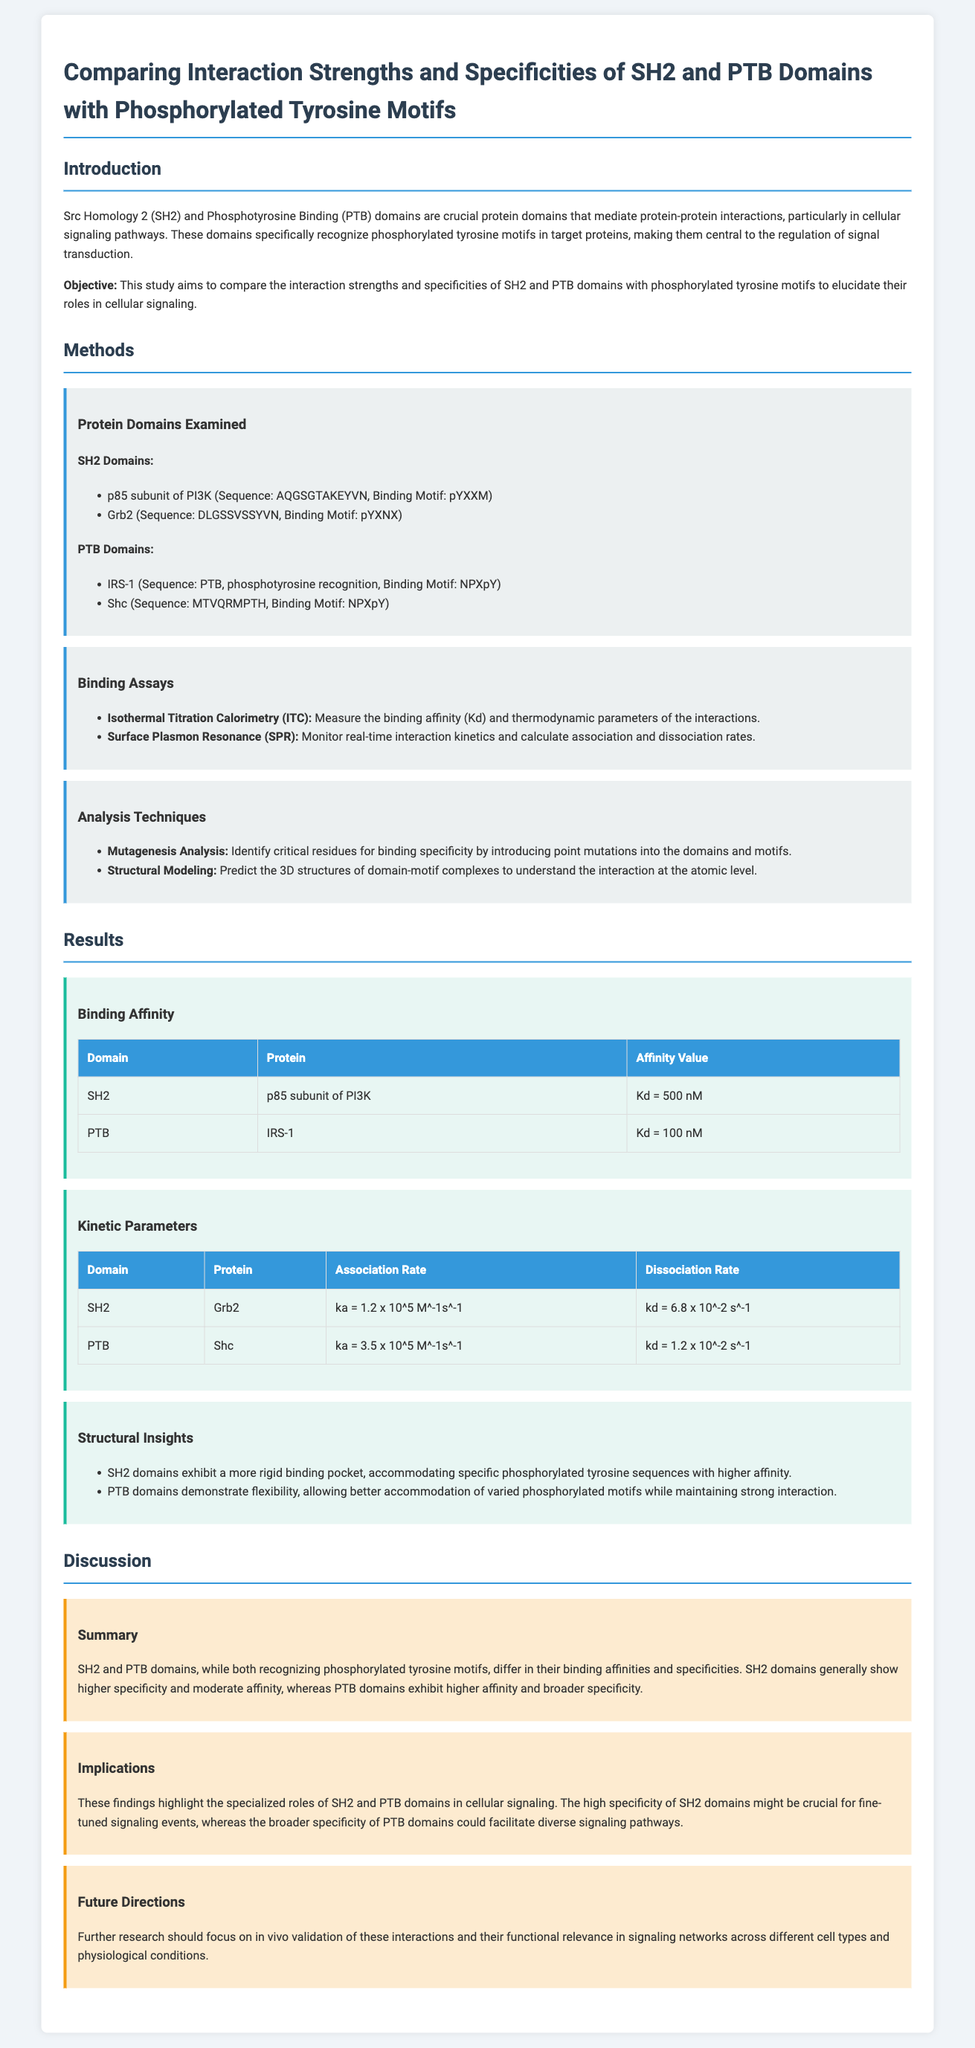What are the two protein domains compared in the study? The document mentions Src Homology 2 (SH2) and Phosphotyrosine Binding (PTB) as the two protein domains compared in the study.
Answer: SH2 and PTB What is the binding motif for the p85 subunit of PI3K? The document specifies the binding motif for the p85 subunit of PI3K as pYXXM.
Answer: pYXXM What is the affinity value of PTB with IRS-1? The document states that the binding affinity value (Kd) of PTB with IRS-1 is 100 nM.
Answer: 100 nM Which method was used to measure binding affinity and thermodynamic parameters? The document lists Isothermal Titration Calorimetry (ITC) as the method used for measuring binding affinity and thermodynamic parameters.
Answer: Isothermal Titration Calorimetry (ITC) Which domain shows higher specificity according to the study? The document mentions that SH2 domains generally show higher specificity.
Answer: SH2 What are the association and dissociation rates for PTB with Shc? The document provides the values for PTB with Shc, which are ka = 3.5 x 10^5 M^-1s^-1 and kd = 1.2 x 10^-2 s^-1.
Answer: ka = 3.5 x 10^5 M^-1s^-1, kd = 1.2 x 10^-2 s^-1 What implication is highlighted regarding the specificity of PTB domains? The document states that the broader specificity of PTB domains could facilitate diverse signaling pathways.
Answer: Facilitate diverse signaling pathways What should future research focus on according to the study? The document suggests that future research should focus on in vivo validation of these interactions and their functional relevance.
Answer: In vivo validation of these interactions 